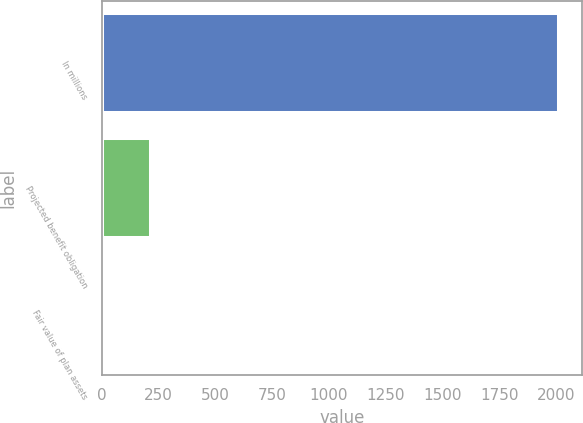Convert chart. <chart><loc_0><loc_0><loc_500><loc_500><bar_chart><fcel>In millions<fcel>Projected benefit obligation<fcel>Fair value of plan assets<nl><fcel>2014<fcel>217.15<fcel>17.5<nl></chart> 